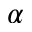<formula> <loc_0><loc_0><loc_500><loc_500>\alpha</formula> 